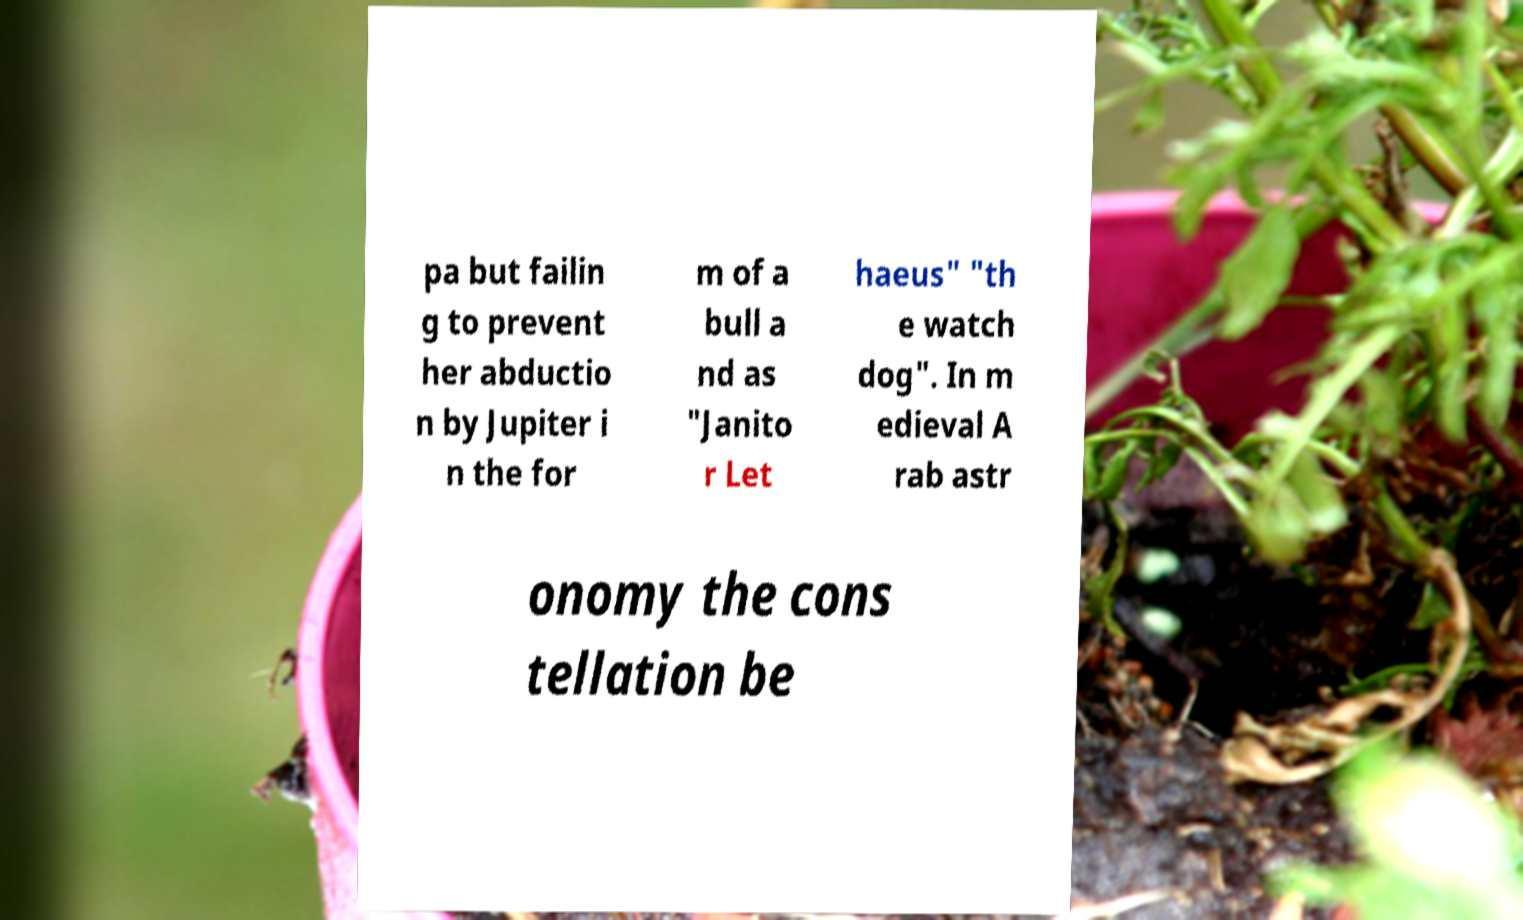What messages or text are displayed in this image? I need them in a readable, typed format. pa but failin g to prevent her abductio n by Jupiter i n the for m of a bull a nd as "Janito r Let haeus" "th e watch dog". In m edieval A rab astr onomy the cons tellation be 